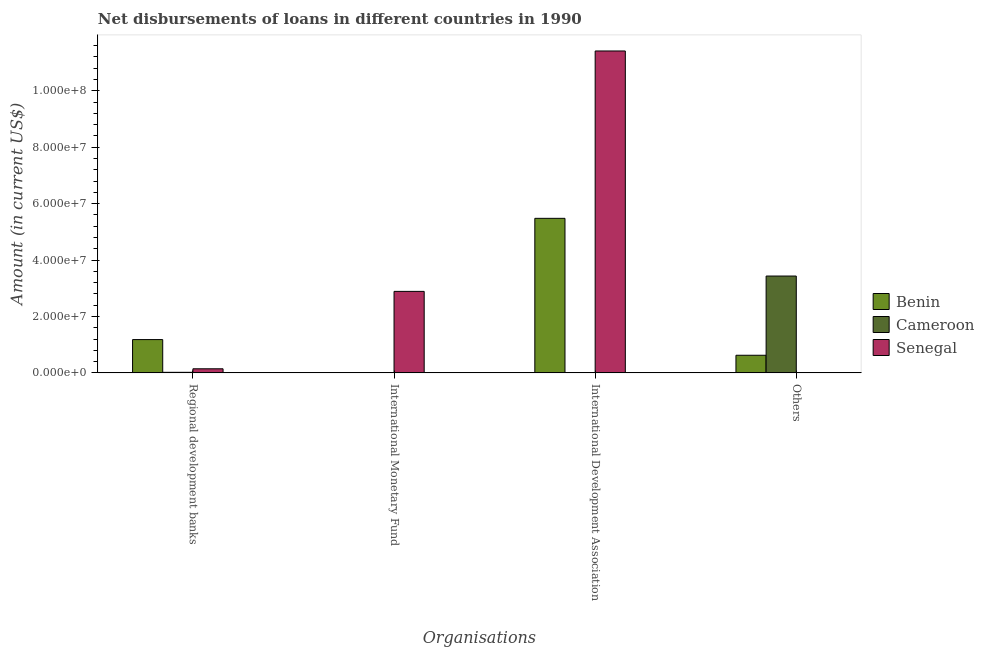How many different coloured bars are there?
Keep it short and to the point. 3. Are the number of bars on each tick of the X-axis equal?
Your answer should be very brief. No. How many bars are there on the 3rd tick from the right?
Keep it short and to the point. 1. What is the label of the 4th group of bars from the left?
Give a very brief answer. Others. What is the amount of loan disimbursed by international development association in Benin?
Offer a very short reply. 5.48e+07. Across all countries, what is the maximum amount of loan disimbursed by regional development banks?
Provide a succinct answer. 1.18e+07. In which country was the amount of loan disimbursed by other organisations maximum?
Your response must be concise. Cameroon. What is the total amount of loan disimbursed by international development association in the graph?
Your answer should be very brief. 1.69e+08. What is the difference between the amount of loan disimbursed by international development association in Senegal and that in Benin?
Provide a succinct answer. 5.93e+07. What is the difference between the amount of loan disimbursed by regional development banks in Cameroon and the amount of loan disimbursed by international development association in Senegal?
Offer a terse response. -1.14e+08. What is the average amount of loan disimbursed by international development association per country?
Your answer should be very brief. 5.63e+07. What is the difference between the amount of loan disimbursed by regional development banks and amount of loan disimbursed by other organisations in Benin?
Your response must be concise. 5.55e+06. What is the ratio of the amount of loan disimbursed by regional development banks in Senegal to that in Cameroon?
Keep it short and to the point. 7.58. Is the difference between the amount of loan disimbursed by international development association in Benin and Senegal greater than the difference between the amount of loan disimbursed by regional development banks in Benin and Senegal?
Ensure brevity in your answer.  No. What is the difference between the highest and the second highest amount of loan disimbursed by regional development banks?
Give a very brief answer. 1.04e+07. What is the difference between the highest and the lowest amount of loan disimbursed by international development association?
Keep it short and to the point. 1.14e+08. In how many countries, is the amount of loan disimbursed by other organisations greater than the average amount of loan disimbursed by other organisations taken over all countries?
Your response must be concise. 1. Are all the bars in the graph horizontal?
Offer a very short reply. No. What is the difference between two consecutive major ticks on the Y-axis?
Provide a succinct answer. 2.00e+07. Are the values on the major ticks of Y-axis written in scientific E-notation?
Provide a succinct answer. Yes. Does the graph contain any zero values?
Give a very brief answer. Yes. What is the title of the graph?
Provide a short and direct response. Net disbursements of loans in different countries in 1990. Does "Palau" appear as one of the legend labels in the graph?
Make the answer very short. No. What is the label or title of the X-axis?
Your answer should be compact. Organisations. What is the Amount (in current US$) of Benin in Regional development banks?
Your response must be concise. 1.18e+07. What is the Amount (in current US$) of Cameroon in Regional development banks?
Keep it short and to the point. 1.91e+05. What is the Amount (in current US$) in Senegal in Regional development banks?
Offer a terse response. 1.45e+06. What is the Amount (in current US$) in Senegal in International Monetary Fund?
Make the answer very short. 2.89e+07. What is the Amount (in current US$) in Benin in International Development Association?
Ensure brevity in your answer.  5.48e+07. What is the Amount (in current US$) of Senegal in International Development Association?
Your answer should be very brief. 1.14e+08. What is the Amount (in current US$) of Benin in Others?
Provide a succinct answer. 6.24e+06. What is the Amount (in current US$) of Cameroon in Others?
Give a very brief answer. 3.43e+07. What is the Amount (in current US$) of Senegal in Others?
Ensure brevity in your answer.  0. Across all Organisations, what is the maximum Amount (in current US$) in Benin?
Give a very brief answer. 5.48e+07. Across all Organisations, what is the maximum Amount (in current US$) in Cameroon?
Offer a terse response. 3.43e+07. Across all Organisations, what is the maximum Amount (in current US$) of Senegal?
Your answer should be compact. 1.14e+08. Across all Organisations, what is the minimum Amount (in current US$) of Senegal?
Make the answer very short. 0. What is the total Amount (in current US$) of Benin in the graph?
Offer a terse response. 7.28e+07. What is the total Amount (in current US$) in Cameroon in the graph?
Your response must be concise. 3.45e+07. What is the total Amount (in current US$) in Senegal in the graph?
Provide a succinct answer. 1.44e+08. What is the difference between the Amount (in current US$) of Senegal in Regional development banks and that in International Monetary Fund?
Your answer should be compact. -2.74e+07. What is the difference between the Amount (in current US$) in Benin in Regional development banks and that in International Development Association?
Provide a succinct answer. -4.30e+07. What is the difference between the Amount (in current US$) of Senegal in Regional development banks and that in International Development Association?
Keep it short and to the point. -1.13e+08. What is the difference between the Amount (in current US$) in Benin in Regional development banks and that in Others?
Your answer should be very brief. 5.55e+06. What is the difference between the Amount (in current US$) in Cameroon in Regional development banks and that in Others?
Keep it short and to the point. -3.41e+07. What is the difference between the Amount (in current US$) in Senegal in International Monetary Fund and that in International Development Association?
Offer a very short reply. -8.52e+07. What is the difference between the Amount (in current US$) of Benin in International Development Association and that in Others?
Offer a very short reply. 4.85e+07. What is the difference between the Amount (in current US$) of Benin in Regional development banks and the Amount (in current US$) of Senegal in International Monetary Fund?
Ensure brevity in your answer.  -1.71e+07. What is the difference between the Amount (in current US$) in Cameroon in Regional development banks and the Amount (in current US$) in Senegal in International Monetary Fund?
Provide a succinct answer. -2.87e+07. What is the difference between the Amount (in current US$) in Benin in Regional development banks and the Amount (in current US$) in Senegal in International Development Association?
Offer a very short reply. -1.02e+08. What is the difference between the Amount (in current US$) of Cameroon in Regional development banks and the Amount (in current US$) of Senegal in International Development Association?
Your answer should be compact. -1.14e+08. What is the difference between the Amount (in current US$) of Benin in Regional development banks and the Amount (in current US$) of Cameroon in Others?
Offer a very short reply. -2.25e+07. What is the difference between the Amount (in current US$) in Benin in International Development Association and the Amount (in current US$) in Cameroon in Others?
Provide a short and direct response. 2.05e+07. What is the average Amount (in current US$) of Benin per Organisations?
Your answer should be compact. 1.82e+07. What is the average Amount (in current US$) in Cameroon per Organisations?
Provide a short and direct response. 8.63e+06. What is the average Amount (in current US$) of Senegal per Organisations?
Keep it short and to the point. 3.61e+07. What is the difference between the Amount (in current US$) of Benin and Amount (in current US$) of Cameroon in Regional development banks?
Offer a very short reply. 1.16e+07. What is the difference between the Amount (in current US$) in Benin and Amount (in current US$) in Senegal in Regional development banks?
Offer a very short reply. 1.04e+07. What is the difference between the Amount (in current US$) in Cameroon and Amount (in current US$) in Senegal in Regional development banks?
Make the answer very short. -1.26e+06. What is the difference between the Amount (in current US$) in Benin and Amount (in current US$) in Senegal in International Development Association?
Your answer should be very brief. -5.93e+07. What is the difference between the Amount (in current US$) in Benin and Amount (in current US$) in Cameroon in Others?
Provide a succinct answer. -2.81e+07. What is the ratio of the Amount (in current US$) of Senegal in Regional development banks to that in International Monetary Fund?
Provide a succinct answer. 0.05. What is the ratio of the Amount (in current US$) in Benin in Regional development banks to that in International Development Association?
Ensure brevity in your answer.  0.22. What is the ratio of the Amount (in current US$) of Senegal in Regional development banks to that in International Development Association?
Ensure brevity in your answer.  0.01. What is the ratio of the Amount (in current US$) in Benin in Regional development banks to that in Others?
Provide a short and direct response. 1.89. What is the ratio of the Amount (in current US$) in Cameroon in Regional development banks to that in Others?
Your answer should be very brief. 0.01. What is the ratio of the Amount (in current US$) of Senegal in International Monetary Fund to that in International Development Association?
Offer a terse response. 0.25. What is the ratio of the Amount (in current US$) in Benin in International Development Association to that in Others?
Give a very brief answer. 8.77. What is the difference between the highest and the second highest Amount (in current US$) in Benin?
Provide a succinct answer. 4.30e+07. What is the difference between the highest and the second highest Amount (in current US$) in Senegal?
Ensure brevity in your answer.  8.52e+07. What is the difference between the highest and the lowest Amount (in current US$) of Benin?
Offer a terse response. 5.48e+07. What is the difference between the highest and the lowest Amount (in current US$) of Cameroon?
Keep it short and to the point. 3.43e+07. What is the difference between the highest and the lowest Amount (in current US$) of Senegal?
Your answer should be very brief. 1.14e+08. 